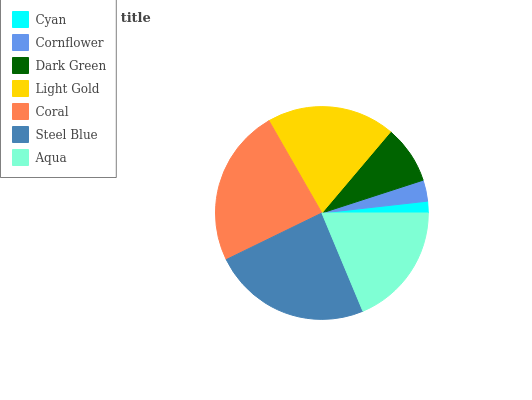Is Cyan the minimum?
Answer yes or no. Yes. Is Steel Blue the maximum?
Answer yes or no. Yes. Is Cornflower the minimum?
Answer yes or no. No. Is Cornflower the maximum?
Answer yes or no. No. Is Cornflower greater than Cyan?
Answer yes or no. Yes. Is Cyan less than Cornflower?
Answer yes or no. Yes. Is Cyan greater than Cornflower?
Answer yes or no. No. Is Cornflower less than Cyan?
Answer yes or no. No. Is Aqua the high median?
Answer yes or no. Yes. Is Aqua the low median?
Answer yes or no. Yes. Is Coral the high median?
Answer yes or no. No. Is Cyan the low median?
Answer yes or no. No. 